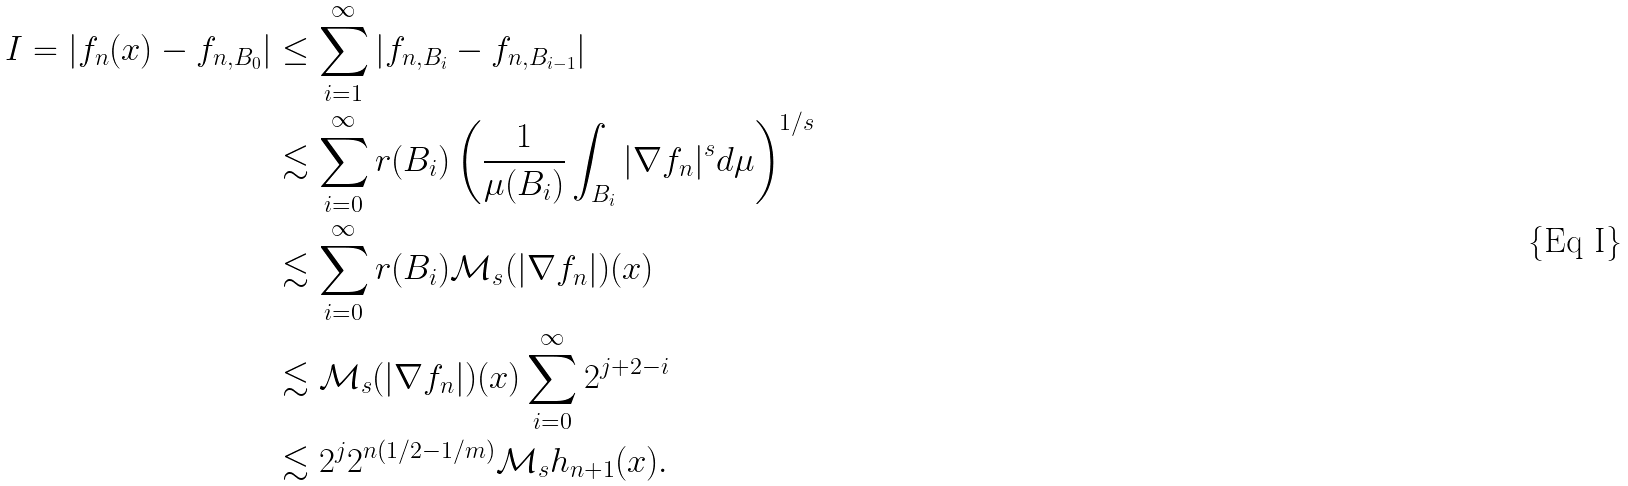<formula> <loc_0><loc_0><loc_500><loc_500>I = | f _ { n } ( x ) - f _ { n , B _ { 0 } } | & \leq \sum _ { i = 1 } ^ { \infty } | f _ { n , B _ { i } } - f _ { n , B _ { i - 1 } } | \\ & \lesssim \sum _ { i = 0 } ^ { \infty } r ( B _ { i } ) \left ( \frac { 1 } { \mu ( B _ { i } ) } \int _ { B _ { i } } | \nabla f _ { n } | ^ { s } d \mu \right ) ^ { 1 / s } \\ & \lesssim \sum _ { i = 0 } ^ { \infty } r ( B _ { i } ) { \mathcal { M } } _ { s } ( | \nabla f _ { n } | ) ( x ) \\ & \lesssim { \mathcal { M } } _ { s } ( | \nabla f _ { n } | ) ( x ) \sum _ { i = 0 } ^ { \infty } 2 ^ { j + 2 - i } \\ & \lesssim 2 ^ { j } 2 ^ { n ( 1 / 2 - 1 / m ) } \mathcal { M } _ { s } h _ { n + 1 } ( x ) .</formula> 